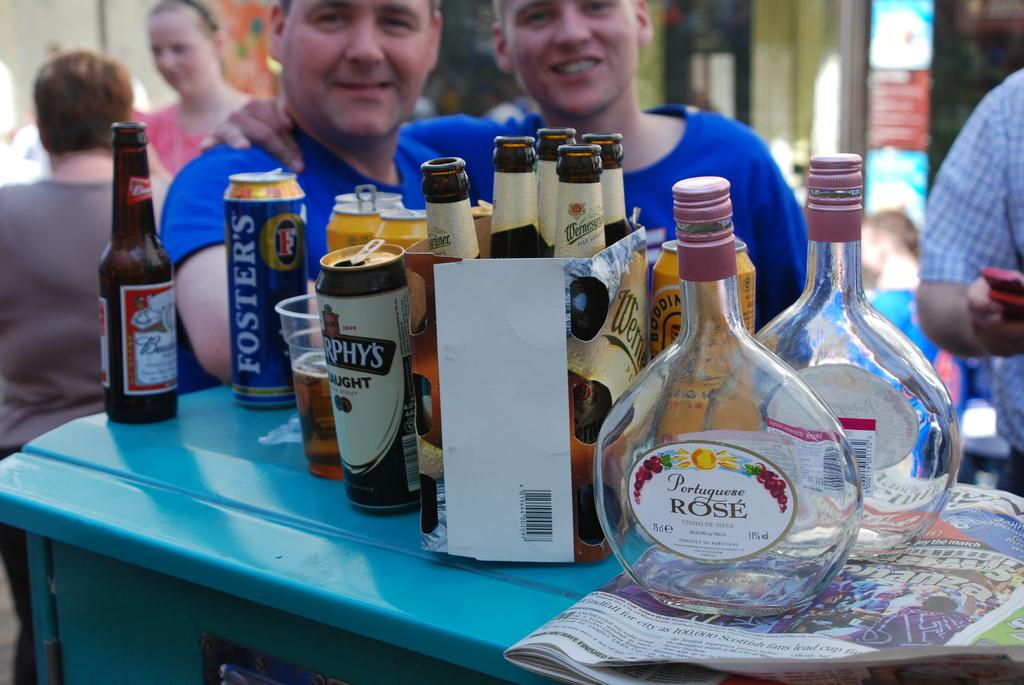Provide a one-sentence caption for the provided image. A group of alcoholic beverages including an empty bottle of Portuguese Rose. 